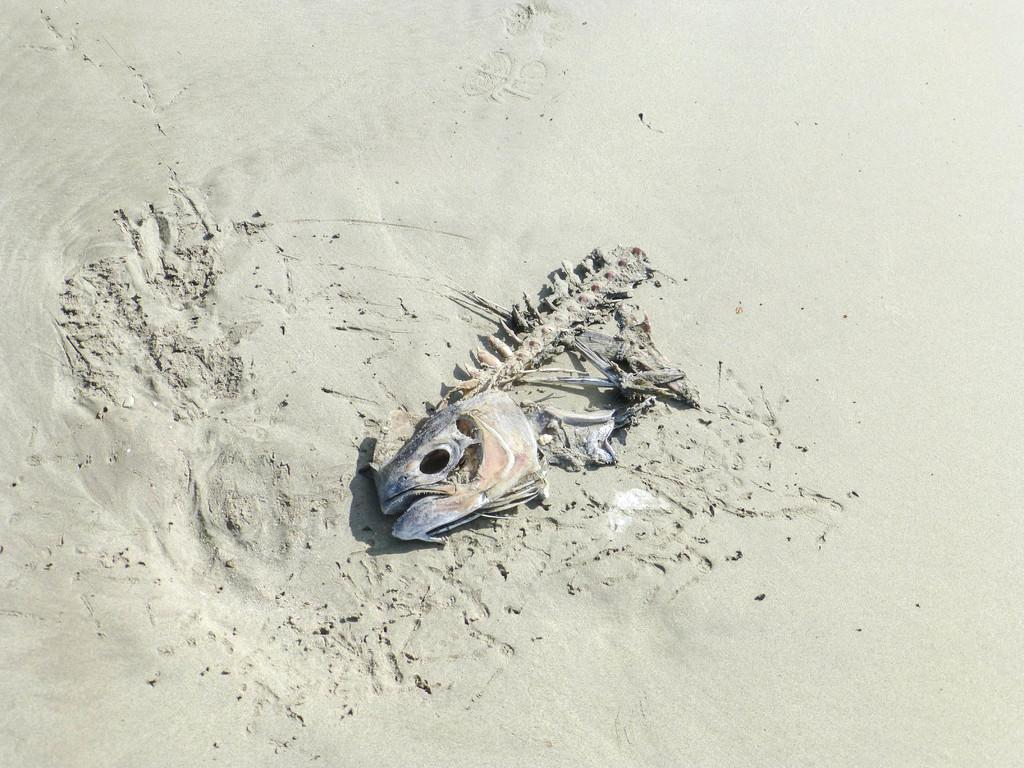What is the main subject of the image? The main subject of the image is a skeleton of an animal. Where is the skeleton located? The skeleton is in the sand. What type of apple is being used to stop the animal's skeleton from moving in the image? There is no apple or any indication of movement in the image; it simply shows a skeleton of an animal in the sand. 